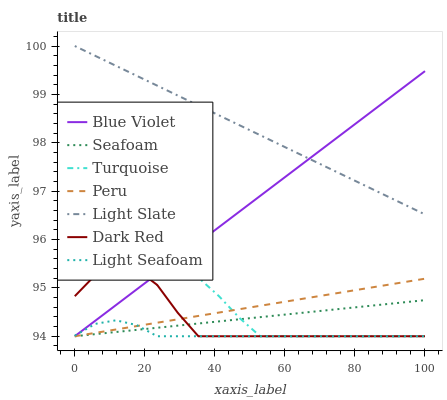Does Light Seafoam have the minimum area under the curve?
Answer yes or no. Yes. Does Light Slate have the maximum area under the curve?
Answer yes or no. Yes. Does Dark Red have the minimum area under the curve?
Answer yes or no. No. Does Dark Red have the maximum area under the curve?
Answer yes or no. No. Is Peru the smoothest?
Answer yes or no. Yes. Is Dark Red the roughest?
Answer yes or no. Yes. Is Light Slate the smoothest?
Answer yes or no. No. Is Light Slate the roughest?
Answer yes or no. No. Does Turquoise have the lowest value?
Answer yes or no. Yes. Does Light Slate have the lowest value?
Answer yes or no. No. Does Light Slate have the highest value?
Answer yes or no. Yes. Does Dark Red have the highest value?
Answer yes or no. No. Is Dark Red less than Light Slate?
Answer yes or no. Yes. Is Light Slate greater than Seafoam?
Answer yes or no. Yes. Does Light Seafoam intersect Seafoam?
Answer yes or no. Yes. Is Light Seafoam less than Seafoam?
Answer yes or no. No. Is Light Seafoam greater than Seafoam?
Answer yes or no. No. Does Dark Red intersect Light Slate?
Answer yes or no. No. 